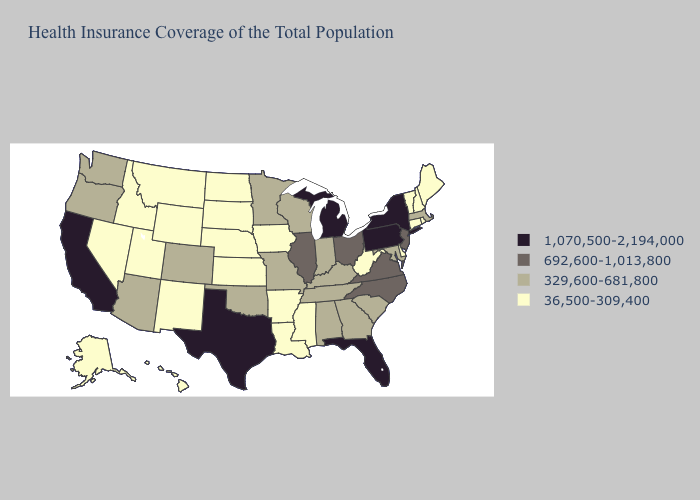What is the highest value in the Northeast ?
Answer briefly. 1,070,500-2,194,000. What is the highest value in states that border Nevada?
Be succinct. 1,070,500-2,194,000. What is the value of Mississippi?
Answer briefly. 36,500-309,400. Does Arkansas have the lowest value in the South?
Concise answer only. Yes. Name the states that have a value in the range 692,600-1,013,800?
Give a very brief answer. Illinois, New Jersey, North Carolina, Ohio, Virginia. What is the value of Indiana?
Concise answer only. 329,600-681,800. Among the states that border Colorado , does Arizona have the highest value?
Quick response, please. Yes. Does New Jersey have the lowest value in the USA?
Give a very brief answer. No. Does Florida have the highest value in the USA?
Concise answer only. Yes. What is the highest value in the South ?
Quick response, please. 1,070,500-2,194,000. Name the states that have a value in the range 36,500-309,400?
Quick response, please. Alaska, Arkansas, Connecticut, Delaware, Hawaii, Idaho, Iowa, Kansas, Louisiana, Maine, Mississippi, Montana, Nebraska, Nevada, New Hampshire, New Mexico, North Dakota, Rhode Island, South Dakota, Utah, Vermont, West Virginia, Wyoming. Name the states that have a value in the range 36,500-309,400?
Short answer required. Alaska, Arkansas, Connecticut, Delaware, Hawaii, Idaho, Iowa, Kansas, Louisiana, Maine, Mississippi, Montana, Nebraska, Nevada, New Hampshire, New Mexico, North Dakota, Rhode Island, South Dakota, Utah, Vermont, West Virginia, Wyoming. Name the states that have a value in the range 329,600-681,800?
Write a very short answer. Alabama, Arizona, Colorado, Georgia, Indiana, Kentucky, Maryland, Massachusetts, Minnesota, Missouri, Oklahoma, Oregon, South Carolina, Tennessee, Washington, Wisconsin. Name the states that have a value in the range 692,600-1,013,800?
Write a very short answer. Illinois, New Jersey, North Carolina, Ohio, Virginia. Which states have the highest value in the USA?
Answer briefly. California, Florida, Michigan, New York, Pennsylvania, Texas. 